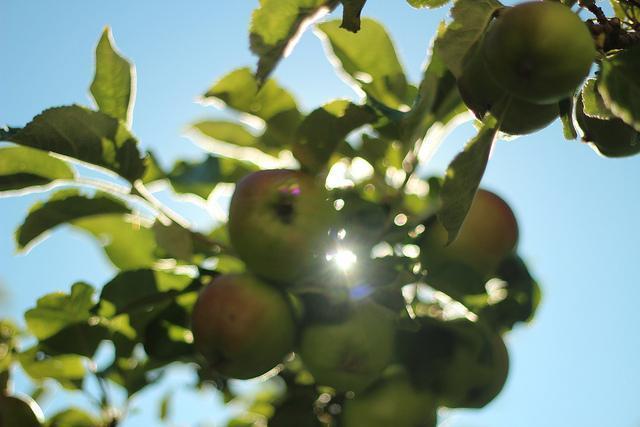How many apples are in the photo?
Give a very brief answer. 8. How many people are wearing black shorts and a black shirt?
Give a very brief answer. 0. 